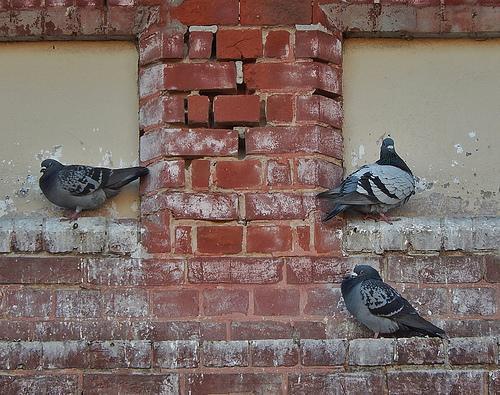How many rock doves in this image have light-colored wings?
Give a very brief answer. 1. 